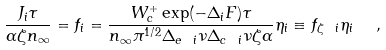Convert formula to latex. <formula><loc_0><loc_0><loc_500><loc_500>\frac { J _ { i } \tau } { \alpha \zeta n _ { \infty } } = f _ { i } = \frac { W ^ { + } _ { c } \exp ( - \Delta _ { i } F ) \tau } { n _ { \infty } \pi ^ { 1 / 2 } \Delta _ { e \ i } \nu \Delta _ { c \ i } \nu \zeta \alpha } \eta _ { i } \equiv f _ { \zeta \ i } \eta _ { i } \ \ ,</formula> 